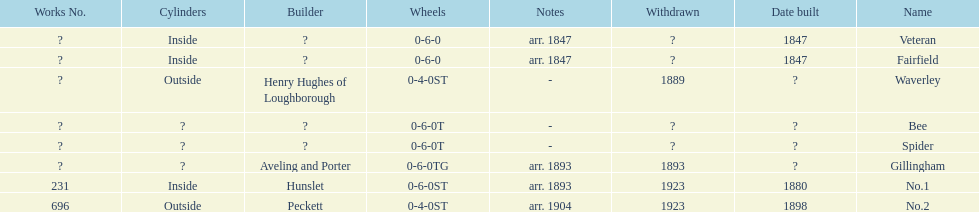Other than fairfield, what else was built in 1847? Veteran. 